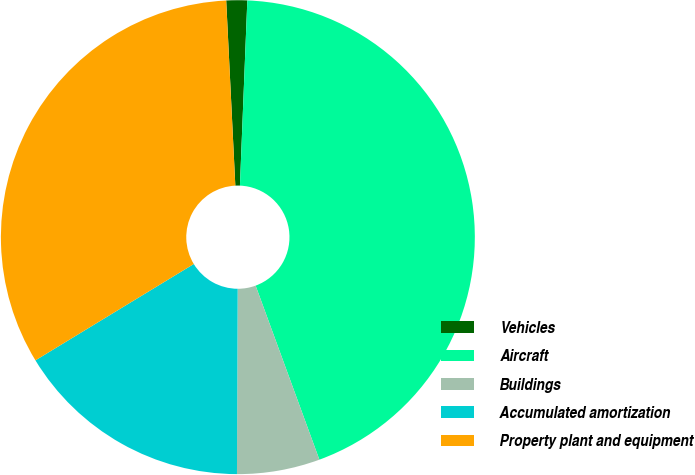Convert chart. <chart><loc_0><loc_0><loc_500><loc_500><pie_chart><fcel>Vehicles<fcel>Aircraft<fcel>Buildings<fcel>Accumulated amortization<fcel>Property plant and equipment<nl><fcel>1.42%<fcel>43.78%<fcel>5.65%<fcel>16.24%<fcel>32.92%<nl></chart> 